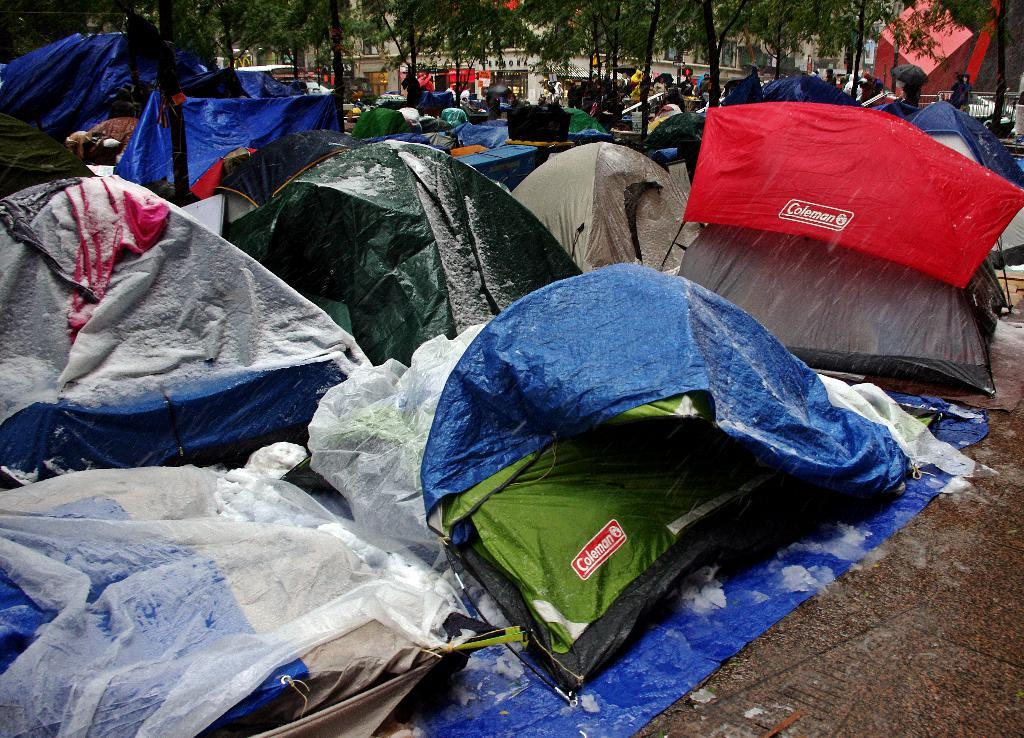What type of temporary shelters are visible in the image? There are a group of tents in the image. What is the condition of the tents? The tents have snow on them. What can be seen in the background of the image? There are people, trees, and buildings in the background of the image. What is at the bottom of the image? There is a walkway at the bottom of the image. What type of dog can be seen on the roof of the tents in the image? There is no dog present on the roof of the tents in the image. What kind of ray is visible in the sky above the tents in the image? There is no ray visible in the sky above the tents in the image. 